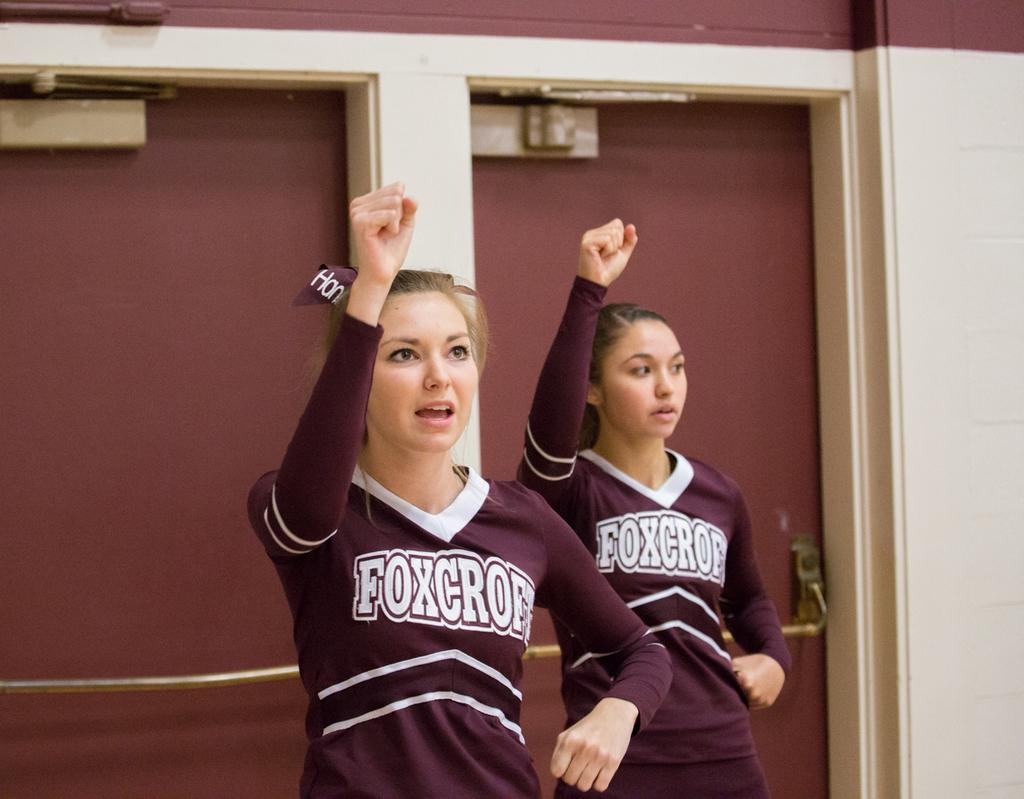How many people are in the image? There are two women standing in the image. What might the women be doing in the image? The women may be dancing. What architectural features can be seen in the image? There are doors and a wall visible in the image. Can you describe any specific details about the doors? There is a door handle visible in the image. What type of wine is being served at the dinner in the image? There is no dinner or wine present in the image; it features two women who may be dancing and architectural features such as doors and a wall. 